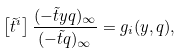Convert formula to latex. <formula><loc_0><loc_0><loc_500><loc_500>\left [ \tilde { t } ^ { i } \right ] \frac { ( - \tilde { t } y q ) _ { \infty } } { ( - \tilde { t } q ) _ { \infty } } = g _ { i } ( y , q ) ,</formula> 